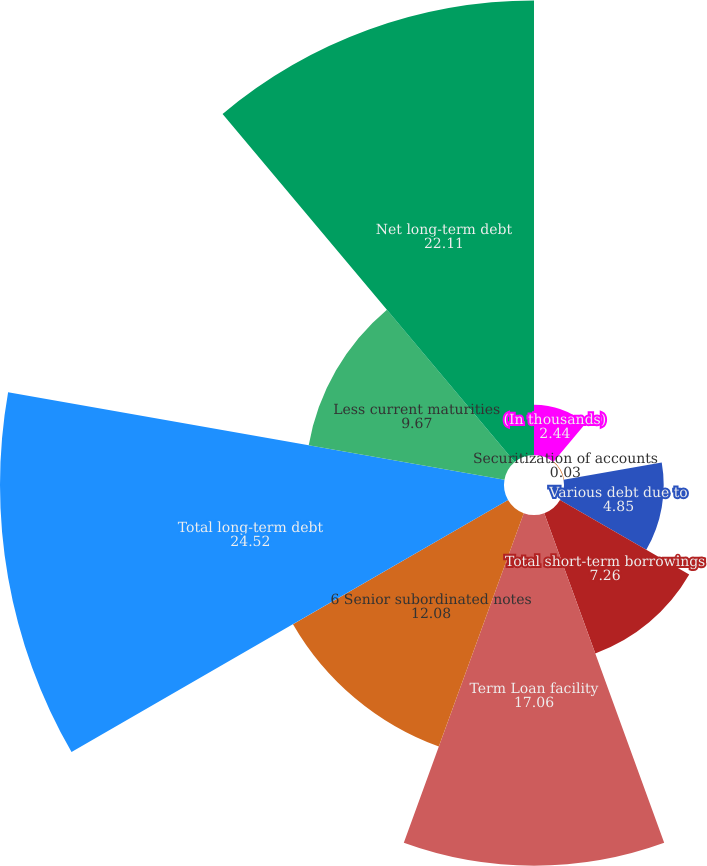Convert chart. <chart><loc_0><loc_0><loc_500><loc_500><pie_chart><fcel>(In thousands)<fcel>Securitization of accounts<fcel>Various debt due to<fcel>Total short-term borrowings<fcel>Term Loan facility<fcel>6 Senior subordinated notes<fcel>Total long-term debt<fcel>Less current maturities<fcel>Net long-term debt<nl><fcel>2.44%<fcel>0.03%<fcel>4.85%<fcel>7.26%<fcel>17.06%<fcel>12.08%<fcel>24.52%<fcel>9.67%<fcel>22.11%<nl></chart> 